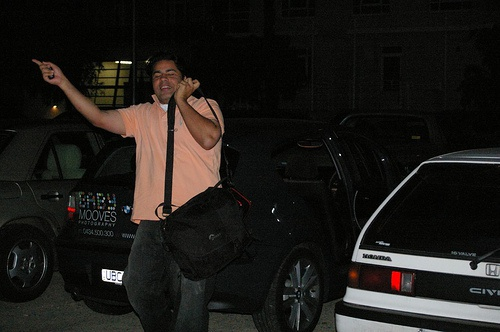Describe the objects in this image and their specific colors. I can see car in black, gray, white, and darkgray tones, car in black, darkgray, lightgray, and gray tones, people in black, salmon, and gray tones, car in black, gray, and purple tones, and handbag in black, gray, and maroon tones in this image. 